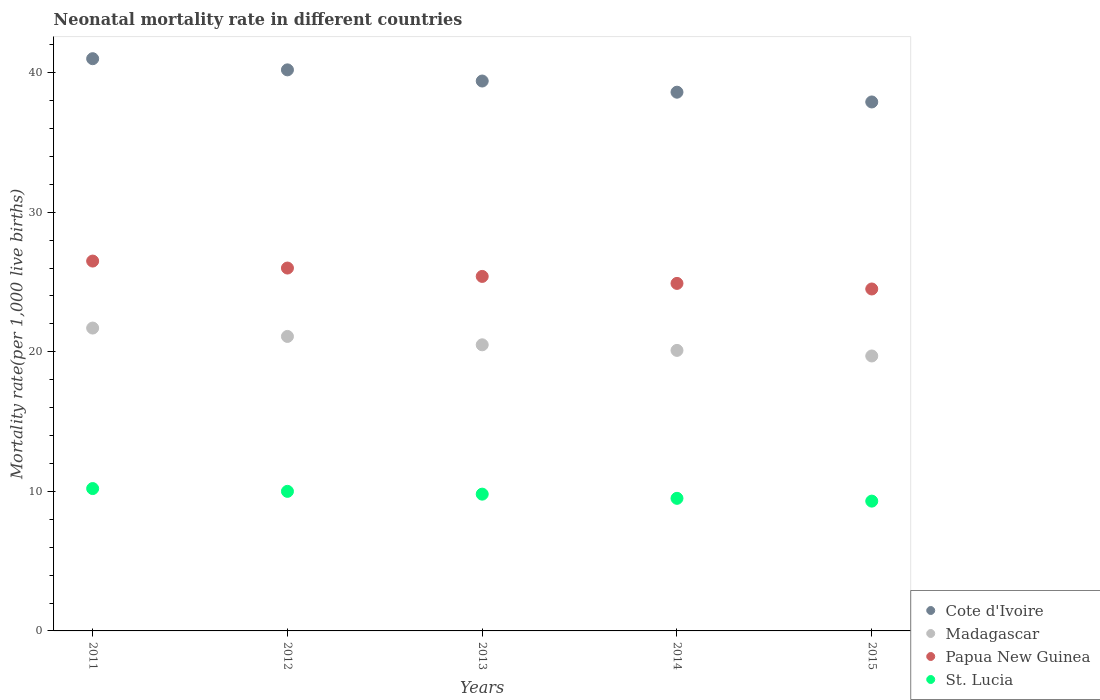How many different coloured dotlines are there?
Make the answer very short. 4. Across all years, what is the maximum neonatal mortality rate in Madagascar?
Ensure brevity in your answer.  21.7. In which year was the neonatal mortality rate in Papua New Guinea minimum?
Make the answer very short. 2015. What is the total neonatal mortality rate in Cote d'Ivoire in the graph?
Give a very brief answer. 197.1. What is the difference between the neonatal mortality rate in St. Lucia in 2012 and that in 2014?
Provide a succinct answer. 0.5. What is the difference between the neonatal mortality rate in St. Lucia in 2014 and the neonatal mortality rate in Papua New Guinea in 2012?
Give a very brief answer. -16.5. What is the average neonatal mortality rate in Madagascar per year?
Provide a short and direct response. 20.62. In the year 2012, what is the difference between the neonatal mortality rate in St. Lucia and neonatal mortality rate in Cote d'Ivoire?
Your response must be concise. -30.2. What is the ratio of the neonatal mortality rate in Madagascar in 2013 to that in 2014?
Give a very brief answer. 1.02. What is the difference between the highest and the second highest neonatal mortality rate in Madagascar?
Your response must be concise. 0.6. What is the difference between the highest and the lowest neonatal mortality rate in Cote d'Ivoire?
Provide a short and direct response. 3.1. Is the sum of the neonatal mortality rate in Papua New Guinea in 2012 and 2015 greater than the maximum neonatal mortality rate in St. Lucia across all years?
Offer a very short reply. Yes. Is it the case that in every year, the sum of the neonatal mortality rate in St. Lucia and neonatal mortality rate in Papua New Guinea  is greater than the sum of neonatal mortality rate in Madagascar and neonatal mortality rate in Cote d'Ivoire?
Your answer should be very brief. No. Does the neonatal mortality rate in St. Lucia monotonically increase over the years?
Your response must be concise. No. Is the neonatal mortality rate in Papua New Guinea strictly less than the neonatal mortality rate in St. Lucia over the years?
Offer a terse response. No. How many years are there in the graph?
Give a very brief answer. 5. Does the graph contain grids?
Ensure brevity in your answer.  No. How many legend labels are there?
Offer a very short reply. 4. How are the legend labels stacked?
Keep it short and to the point. Vertical. What is the title of the graph?
Provide a succinct answer. Neonatal mortality rate in different countries. What is the label or title of the X-axis?
Offer a terse response. Years. What is the label or title of the Y-axis?
Offer a terse response. Mortality rate(per 1,0 live births). What is the Mortality rate(per 1,000 live births) in Madagascar in 2011?
Offer a very short reply. 21.7. What is the Mortality rate(per 1,000 live births) of St. Lucia in 2011?
Your answer should be compact. 10.2. What is the Mortality rate(per 1,000 live births) of Cote d'Ivoire in 2012?
Provide a short and direct response. 40.2. What is the Mortality rate(per 1,000 live births) in Madagascar in 2012?
Provide a short and direct response. 21.1. What is the Mortality rate(per 1,000 live births) in St. Lucia in 2012?
Provide a short and direct response. 10. What is the Mortality rate(per 1,000 live births) in Cote d'Ivoire in 2013?
Ensure brevity in your answer.  39.4. What is the Mortality rate(per 1,000 live births) in Madagascar in 2013?
Keep it short and to the point. 20.5. What is the Mortality rate(per 1,000 live births) in Papua New Guinea in 2013?
Make the answer very short. 25.4. What is the Mortality rate(per 1,000 live births) in St. Lucia in 2013?
Ensure brevity in your answer.  9.8. What is the Mortality rate(per 1,000 live births) in Cote d'Ivoire in 2014?
Offer a terse response. 38.6. What is the Mortality rate(per 1,000 live births) of Madagascar in 2014?
Offer a very short reply. 20.1. What is the Mortality rate(per 1,000 live births) of Papua New Guinea in 2014?
Offer a very short reply. 24.9. What is the Mortality rate(per 1,000 live births) in St. Lucia in 2014?
Offer a very short reply. 9.5. What is the Mortality rate(per 1,000 live births) of Cote d'Ivoire in 2015?
Your answer should be very brief. 37.9. What is the Mortality rate(per 1,000 live births) in Madagascar in 2015?
Keep it short and to the point. 19.7. What is the Mortality rate(per 1,000 live births) of Papua New Guinea in 2015?
Your answer should be compact. 24.5. What is the Mortality rate(per 1,000 live births) of St. Lucia in 2015?
Give a very brief answer. 9.3. Across all years, what is the maximum Mortality rate(per 1,000 live births) in Cote d'Ivoire?
Your answer should be compact. 41. Across all years, what is the maximum Mortality rate(per 1,000 live births) in Madagascar?
Offer a very short reply. 21.7. Across all years, what is the minimum Mortality rate(per 1,000 live births) of Cote d'Ivoire?
Give a very brief answer. 37.9. Across all years, what is the minimum Mortality rate(per 1,000 live births) of Madagascar?
Ensure brevity in your answer.  19.7. What is the total Mortality rate(per 1,000 live births) of Cote d'Ivoire in the graph?
Make the answer very short. 197.1. What is the total Mortality rate(per 1,000 live births) of Madagascar in the graph?
Make the answer very short. 103.1. What is the total Mortality rate(per 1,000 live births) of Papua New Guinea in the graph?
Provide a succinct answer. 127.3. What is the total Mortality rate(per 1,000 live births) in St. Lucia in the graph?
Ensure brevity in your answer.  48.8. What is the difference between the Mortality rate(per 1,000 live births) in Madagascar in 2011 and that in 2012?
Give a very brief answer. 0.6. What is the difference between the Mortality rate(per 1,000 live births) of Papua New Guinea in 2011 and that in 2012?
Keep it short and to the point. 0.5. What is the difference between the Mortality rate(per 1,000 live births) in St. Lucia in 2011 and that in 2012?
Offer a terse response. 0.2. What is the difference between the Mortality rate(per 1,000 live births) of Cote d'Ivoire in 2011 and that in 2013?
Offer a very short reply. 1.6. What is the difference between the Mortality rate(per 1,000 live births) of Papua New Guinea in 2011 and that in 2013?
Your answer should be compact. 1.1. What is the difference between the Mortality rate(per 1,000 live births) in Papua New Guinea in 2011 and that in 2014?
Offer a very short reply. 1.6. What is the difference between the Mortality rate(per 1,000 live births) in St. Lucia in 2011 and that in 2014?
Provide a succinct answer. 0.7. What is the difference between the Mortality rate(per 1,000 live births) in Papua New Guinea in 2011 and that in 2015?
Your answer should be very brief. 2. What is the difference between the Mortality rate(per 1,000 live births) in St. Lucia in 2011 and that in 2015?
Provide a succinct answer. 0.9. What is the difference between the Mortality rate(per 1,000 live births) of Madagascar in 2012 and that in 2013?
Offer a terse response. 0.6. What is the difference between the Mortality rate(per 1,000 live births) in Papua New Guinea in 2012 and that in 2013?
Offer a very short reply. 0.6. What is the difference between the Mortality rate(per 1,000 live births) in St. Lucia in 2012 and that in 2013?
Your answer should be compact. 0.2. What is the difference between the Mortality rate(per 1,000 live births) in Madagascar in 2012 and that in 2014?
Your answer should be compact. 1. What is the difference between the Mortality rate(per 1,000 live births) in Cote d'Ivoire in 2012 and that in 2015?
Your answer should be very brief. 2.3. What is the difference between the Mortality rate(per 1,000 live births) in Cote d'Ivoire in 2013 and that in 2014?
Keep it short and to the point. 0.8. What is the difference between the Mortality rate(per 1,000 live births) in St. Lucia in 2013 and that in 2014?
Offer a terse response. 0.3. What is the difference between the Mortality rate(per 1,000 live births) of Cote d'Ivoire in 2013 and that in 2015?
Give a very brief answer. 1.5. What is the difference between the Mortality rate(per 1,000 live births) in Papua New Guinea in 2013 and that in 2015?
Provide a short and direct response. 0.9. What is the difference between the Mortality rate(per 1,000 live births) in Cote d'Ivoire in 2014 and that in 2015?
Offer a terse response. 0.7. What is the difference between the Mortality rate(per 1,000 live births) in Madagascar in 2014 and that in 2015?
Your response must be concise. 0.4. What is the difference between the Mortality rate(per 1,000 live births) of Papua New Guinea in 2014 and that in 2015?
Provide a short and direct response. 0.4. What is the difference between the Mortality rate(per 1,000 live births) of Cote d'Ivoire in 2011 and the Mortality rate(per 1,000 live births) of Madagascar in 2012?
Provide a short and direct response. 19.9. What is the difference between the Mortality rate(per 1,000 live births) in Madagascar in 2011 and the Mortality rate(per 1,000 live births) in Papua New Guinea in 2012?
Provide a succinct answer. -4.3. What is the difference between the Mortality rate(per 1,000 live births) of Madagascar in 2011 and the Mortality rate(per 1,000 live births) of St. Lucia in 2012?
Keep it short and to the point. 11.7. What is the difference between the Mortality rate(per 1,000 live births) of Papua New Guinea in 2011 and the Mortality rate(per 1,000 live births) of St. Lucia in 2012?
Your response must be concise. 16.5. What is the difference between the Mortality rate(per 1,000 live births) of Cote d'Ivoire in 2011 and the Mortality rate(per 1,000 live births) of St. Lucia in 2013?
Your response must be concise. 31.2. What is the difference between the Mortality rate(per 1,000 live births) in Madagascar in 2011 and the Mortality rate(per 1,000 live births) in Papua New Guinea in 2013?
Offer a very short reply. -3.7. What is the difference between the Mortality rate(per 1,000 live births) in Madagascar in 2011 and the Mortality rate(per 1,000 live births) in St. Lucia in 2013?
Provide a short and direct response. 11.9. What is the difference between the Mortality rate(per 1,000 live births) of Cote d'Ivoire in 2011 and the Mortality rate(per 1,000 live births) of Madagascar in 2014?
Offer a terse response. 20.9. What is the difference between the Mortality rate(per 1,000 live births) in Cote d'Ivoire in 2011 and the Mortality rate(per 1,000 live births) in Papua New Guinea in 2014?
Keep it short and to the point. 16.1. What is the difference between the Mortality rate(per 1,000 live births) of Cote d'Ivoire in 2011 and the Mortality rate(per 1,000 live births) of St. Lucia in 2014?
Your response must be concise. 31.5. What is the difference between the Mortality rate(per 1,000 live births) in Papua New Guinea in 2011 and the Mortality rate(per 1,000 live births) in St. Lucia in 2014?
Your response must be concise. 17. What is the difference between the Mortality rate(per 1,000 live births) in Cote d'Ivoire in 2011 and the Mortality rate(per 1,000 live births) in Madagascar in 2015?
Ensure brevity in your answer.  21.3. What is the difference between the Mortality rate(per 1,000 live births) of Cote d'Ivoire in 2011 and the Mortality rate(per 1,000 live births) of Papua New Guinea in 2015?
Your response must be concise. 16.5. What is the difference between the Mortality rate(per 1,000 live births) in Cote d'Ivoire in 2011 and the Mortality rate(per 1,000 live births) in St. Lucia in 2015?
Your answer should be compact. 31.7. What is the difference between the Mortality rate(per 1,000 live births) in Madagascar in 2011 and the Mortality rate(per 1,000 live births) in Papua New Guinea in 2015?
Provide a succinct answer. -2.8. What is the difference between the Mortality rate(per 1,000 live births) in Papua New Guinea in 2011 and the Mortality rate(per 1,000 live births) in St. Lucia in 2015?
Your answer should be compact. 17.2. What is the difference between the Mortality rate(per 1,000 live births) in Cote d'Ivoire in 2012 and the Mortality rate(per 1,000 live births) in St. Lucia in 2013?
Keep it short and to the point. 30.4. What is the difference between the Mortality rate(per 1,000 live births) of Madagascar in 2012 and the Mortality rate(per 1,000 live births) of St. Lucia in 2013?
Ensure brevity in your answer.  11.3. What is the difference between the Mortality rate(per 1,000 live births) of Papua New Guinea in 2012 and the Mortality rate(per 1,000 live births) of St. Lucia in 2013?
Ensure brevity in your answer.  16.2. What is the difference between the Mortality rate(per 1,000 live births) in Cote d'Ivoire in 2012 and the Mortality rate(per 1,000 live births) in Madagascar in 2014?
Offer a terse response. 20.1. What is the difference between the Mortality rate(per 1,000 live births) in Cote d'Ivoire in 2012 and the Mortality rate(per 1,000 live births) in Papua New Guinea in 2014?
Offer a terse response. 15.3. What is the difference between the Mortality rate(per 1,000 live births) in Cote d'Ivoire in 2012 and the Mortality rate(per 1,000 live births) in St. Lucia in 2014?
Provide a succinct answer. 30.7. What is the difference between the Mortality rate(per 1,000 live births) in Madagascar in 2012 and the Mortality rate(per 1,000 live births) in Papua New Guinea in 2014?
Provide a short and direct response. -3.8. What is the difference between the Mortality rate(per 1,000 live births) in Cote d'Ivoire in 2012 and the Mortality rate(per 1,000 live births) in Madagascar in 2015?
Your answer should be compact. 20.5. What is the difference between the Mortality rate(per 1,000 live births) of Cote d'Ivoire in 2012 and the Mortality rate(per 1,000 live births) of St. Lucia in 2015?
Your answer should be very brief. 30.9. What is the difference between the Mortality rate(per 1,000 live births) of Madagascar in 2012 and the Mortality rate(per 1,000 live births) of Papua New Guinea in 2015?
Offer a very short reply. -3.4. What is the difference between the Mortality rate(per 1,000 live births) of Cote d'Ivoire in 2013 and the Mortality rate(per 1,000 live births) of Madagascar in 2014?
Your answer should be compact. 19.3. What is the difference between the Mortality rate(per 1,000 live births) of Cote d'Ivoire in 2013 and the Mortality rate(per 1,000 live births) of St. Lucia in 2014?
Offer a terse response. 29.9. What is the difference between the Mortality rate(per 1,000 live births) of Madagascar in 2013 and the Mortality rate(per 1,000 live births) of Papua New Guinea in 2014?
Your answer should be compact. -4.4. What is the difference between the Mortality rate(per 1,000 live births) in Papua New Guinea in 2013 and the Mortality rate(per 1,000 live births) in St. Lucia in 2014?
Ensure brevity in your answer.  15.9. What is the difference between the Mortality rate(per 1,000 live births) of Cote d'Ivoire in 2013 and the Mortality rate(per 1,000 live births) of St. Lucia in 2015?
Keep it short and to the point. 30.1. What is the difference between the Mortality rate(per 1,000 live births) in Madagascar in 2013 and the Mortality rate(per 1,000 live births) in St. Lucia in 2015?
Your response must be concise. 11.2. What is the difference between the Mortality rate(per 1,000 live births) in Papua New Guinea in 2013 and the Mortality rate(per 1,000 live births) in St. Lucia in 2015?
Give a very brief answer. 16.1. What is the difference between the Mortality rate(per 1,000 live births) in Cote d'Ivoire in 2014 and the Mortality rate(per 1,000 live births) in Madagascar in 2015?
Provide a short and direct response. 18.9. What is the difference between the Mortality rate(per 1,000 live births) in Cote d'Ivoire in 2014 and the Mortality rate(per 1,000 live births) in St. Lucia in 2015?
Make the answer very short. 29.3. What is the difference between the Mortality rate(per 1,000 live births) in Papua New Guinea in 2014 and the Mortality rate(per 1,000 live births) in St. Lucia in 2015?
Ensure brevity in your answer.  15.6. What is the average Mortality rate(per 1,000 live births) of Cote d'Ivoire per year?
Offer a very short reply. 39.42. What is the average Mortality rate(per 1,000 live births) in Madagascar per year?
Provide a short and direct response. 20.62. What is the average Mortality rate(per 1,000 live births) of Papua New Guinea per year?
Give a very brief answer. 25.46. What is the average Mortality rate(per 1,000 live births) of St. Lucia per year?
Your response must be concise. 9.76. In the year 2011, what is the difference between the Mortality rate(per 1,000 live births) in Cote d'Ivoire and Mortality rate(per 1,000 live births) in Madagascar?
Provide a short and direct response. 19.3. In the year 2011, what is the difference between the Mortality rate(per 1,000 live births) in Cote d'Ivoire and Mortality rate(per 1,000 live births) in Papua New Guinea?
Your answer should be compact. 14.5. In the year 2011, what is the difference between the Mortality rate(per 1,000 live births) in Cote d'Ivoire and Mortality rate(per 1,000 live births) in St. Lucia?
Your answer should be very brief. 30.8. In the year 2011, what is the difference between the Mortality rate(per 1,000 live births) of Madagascar and Mortality rate(per 1,000 live births) of Papua New Guinea?
Your answer should be very brief. -4.8. In the year 2011, what is the difference between the Mortality rate(per 1,000 live births) in Papua New Guinea and Mortality rate(per 1,000 live births) in St. Lucia?
Offer a very short reply. 16.3. In the year 2012, what is the difference between the Mortality rate(per 1,000 live births) in Cote d'Ivoire and Mortality rate(per 1,000 live births) in Madagascar?
Offer a very short reply. 19.1. In the year 2012, what is the difference between the Mortality rate(per 1,000 live births) in Cote d'Ivoire and Mortality rate(per 1,000 live births) in Papua New Guinea?
Your answer should be very brief. 14.2. In the year 2012, what is the difference between the Mortality rate(per 1,000 live births) of Cote d'Ivoire and Mortality rate(per 1,000 live births) of St. Lucia?
Offer a very short reply. 30.2. In the year 2013, what is the difference between the Mortality rate(per 1,000 live births) of Cote d'Ivoire and Mortality rate(per 1,000 live births) of Madagascar?
Ensure brevity in your answer.  18.9. In the year 2013, what is the difference between the Mortality rate(per 1,000 live births) in Cote d'Ivoire and Mortality rate(per 1,000 live births) in Papua New Guinea?
Ensure brevity in your answer.  14. In the year 2013, what is the difference between the Mortality rate(per 1,000 live births) in Cote d'Ivoire and Mortality rate(per 1,000 live births) in St. Lucia?
Give a very brief answer. 29.6. In the year 2013, what is the difference between the Mortality rate(per 1,000 live births) of Madagascar and Mortality rate(per 1,000 live births) of Papua New Guinea?
Make the answer very short. -4.9. In the year 2013, what is the difference between the Mortality rate(per 1,000 live births) of Papua New Guinea and Mortality rate(per 1,000 live births) of St. Lucia?
Make the answer very short. 15.6. In the year 2014, what is the difference between the Mortality rate(per 1,000 live births) in Cote d'Ivoire and Mortality rate(per 1,000 live births) in Madagascar?
Ensure brevity in your answer.  18.5. In the year 2014, what is the difference between the Mortality rate(per 1,000 live births) in Cote d'Ivoire and Mortality rate(per 1,000 live births) in St. Lucia?
Keep it short and to the point. 29.1. In the year 2015, what is the difference between the Mortality rate(per 1,000 live births) of Cote d'Ivoire and Mortality rate(per 1,000 live births) of Madagascar?
Your answer should be very brief. 18.2. In the year 2015, what is the difference between the Mortality rate(per 1,000 live births) in Cote d'Ivoire and Mortality rate(per 1,000 live births) in Papua New Guinea?
Give a very brief answer. 13.4. In the year 2015, what is the difference between the Mortality rate(per 1,000 live births) in Cote d'Ivoire and Mortality rate(per 1,000 live births) in St. Lucia?
Give a very brief answer. 28.6. In the year 2015, what is the difference between the Mortality rate(per 1,000 live births) of Madagascar and Mortality rate(per 1,000 live births) of St. Lucia?
Provide a short and direct response. 10.4. In the year 2015, what is the difference between the Mortality rate(per 1,000 live births) in Papua New Guinea and Mortality rate(per 1,000 live births) in St. Lucia?
Offer a terse response. 15.2. What is the ratio of the Mortality rate(per 1,000 live births) in Cote d'Ivoire in 2011 to that in 2012?
Give a very brief answer. 1.02. What is the ratio of the Mortality rate(per 1,000 live births) of Madagascar in 2011 to that in 2012?
Offer a very short reply. 1.03. What is the ratio of the Mortality rate(per 1,000 live births) of Papua New Guinea in 2011 to that in 2012?
Make the answer very short. 1.02. What is the ratio of the Mortality rate(per 1,000 live births) in Cote d'Ivoire in 2011 to that in 2013?
Ensure brevity in your answer.  1.04. What is the ratio of the Mortality rate(per 1,000 live births) in Madagascar in 2011 to that in 2013?
Offer a terse response. 1.06. What is the ratio of the Mortality rate(per 1,000 live births) in Papua New Guinea in 2011 to that in 2013?
Give a very brief answer. 1.04. What is the ratio of the Mortality rate(per 1,000 live births) of St. Lucia in 2011 to that in 2013?
Your response must be concise. 1.04. What is the ratio of the Mortality rate(per 1,000 live births) of Cote d'Ivoire in 2011 to that in 2014?
Provide a short and direct response. 1.06. What is the ratio of the Mortality rate(per 1,000 live births) in Madagascar in 2011 to that in 2014?
Offer a terse response. 1.08. What is the ratio of the Mortality rate(per 1,000 live births) of Papua New Guinea in 2011 to that in 2014?
Your answer should be compact. 1.06. What is the ratio of the Mortality rate(per 1,000 live births) of St. Lucia in 2011 to that in 2014?
Your answer should be compact. 1.07. What is the ratio of the Mortality rate(per 1,000 live births) in Cote d'Ivoire in 2011 to that in 2015?
Offer a very short reply. 1.08. What is the ratio of the Mortality rate(per 1,000 live births) of Madagascar in 2011 to that in 2015?
Your answer should be compact. 1.1. What is the ratio of the Mortality rate(per 1,000 live births) in Papua New Guinea in 2011 to that in 2015?
Your answer should be very brief. 1.08. What is the ratio of the Mortality rate(per 1,000 live births) of St. Lucia in 2011 to that in 2015?
Provide a short and direct response. 1.1. What is the ratio of the Mortality rate(per 1,000 live births) in Cote d'Ivoire in 2012 to that in 2013?
Give a very brief answer. 1.02. What is the ratio of the Mortality rate(per 1,000 live births) in Madagascar in 2012 to that in 2013?
Make the answer very short. 1.03. What is the ratio of the Mortality rate(per 1,000 live births) in Papua New Guinea in 2012 to that in 2013?
Provide a succinct answer. 1.02. What is the ratio of the Mortality rate(per 1,000 live births) of St. Lucia in 2012 to that in 2013?
Offer a very short reply. 1.02. What is the ratio of the Mortality rate(per 1,000 live births) of Cote d'Ivoire in 2012 to that in 2014?
Make the answer very short. 1.04. What is the ratio of the Mortality rate(per 1,000 live births) of Madagascar in 2012 to that in 2014?
Keep it short and to the point. 1.05. What is the ratio of the Mortality rate(per 1,000 live births) in Papua New Guinea in 2012 to that in 2014?
Ensure brevity in your answer.  1.04. What is the ratio of the Mortality rate(per 1,000 live births) in St. Lucia in 2012 to that in 2014?
Keep it short and to the point. 1.05. What is the ratio of the Mortality rate(per 1,000 live births) in Cote d'Ivoire in 2012 to that in 2015?
Your response must be concise. 1.06. What is the ratio of the Mortality rate(per 1,000 live births) in Madagascar in 2012 to that in 2015?
Your answer should be very brief. 1.07. What is the ratio of the Mortality rate(per 1,000 live births) in Papua New Guinea in 2012 to that in 2015?
Your answer should be compact. 1.06. What is the ratio of the Mortality rate(per 1,000 live births) of St. Lucia in 2012 to that in 2015?
Ensure brevity in your answer.  1.08. What is the ratio of the Mortality rate(per 1,000 live births) of Cote d'Ivoire in 2013 to that in 2014?
Provide a succinct answer. 1.02. What is the ratio of the Mortality rate(per 1,000 live births) of Madagascar in 2013 to that in 2014?
Offer a terse response. 1.02. What is the ratio of the Mortality rate(per 1,000 live births) of Papua New Guinea in 2013 to that in 2014?
Make the answer very short. 1.02. What is the ratio of the Mortality rate(per 1,000 live births) of St. Lucia in 2013 to that in 2014?
Your answer should be compact. 1.03. What is the ratio of the Mortality rate(per 1,000 live births) in Cote d'Ivoire in 2013 to that in 2015?
Provide a succinct answer. 1.04. What is the ratio of the Mortality rate(per 1,000 live births) of Madagascar in 2013 to that in 2015?
Give a very brief answer. 1.04. What is the ratio of the Mortality rate(per 1,000 live births) of Papua New Guinea in 2013 to that in 2015?
Keep it short and to the point. 1.04. What is the ratio of the Mortality rate(per 1,000 live births) in St. Lucia in 2013 to that in 2015?
Your answer should be very brief. 1.05. What is the ratio of the Mortality rate(per 1,000 live births) in Cote d'Ivoire in 2014 to that in 2015?
Give a very brief answer. 1.02. What is the ratio of the Mortality rate(per 1,000 live births) of Madagascar in 2014 to that in 2015?
Your response must be concise. 1.02. What is the ratio of the Mortality rate(per 1,000 live births) of Papua New Guinea in 2014 to that in 2015?
Your response must be concise. 1.02. What is the ratio of the Mortality rate(per 1,000 live births) of St. Lucia in 2014 to that in 2015?
Keep it short and to the point. 1.02. What is the difference between the highest and the second highest Mortality rate(per 1,000 live births) in Cote d'Ivoire?
Make the answer very short. 0.8. What is the difference between the highest and the second highest Mortality rate(per 1,000 live births) in Madagascar?
Provide a succinct answer. 0.6. What is the difference between the highest and the lowest Mortality rate(per 1,000 live births) of Cote d'Ivoire?
Ensure brevity in your answer.  3.1. What is the difference between the highest and the lowest Mortality rate(per 1,000 live births) in St. Lucia?
Keep it short and to the point. 0.9. 